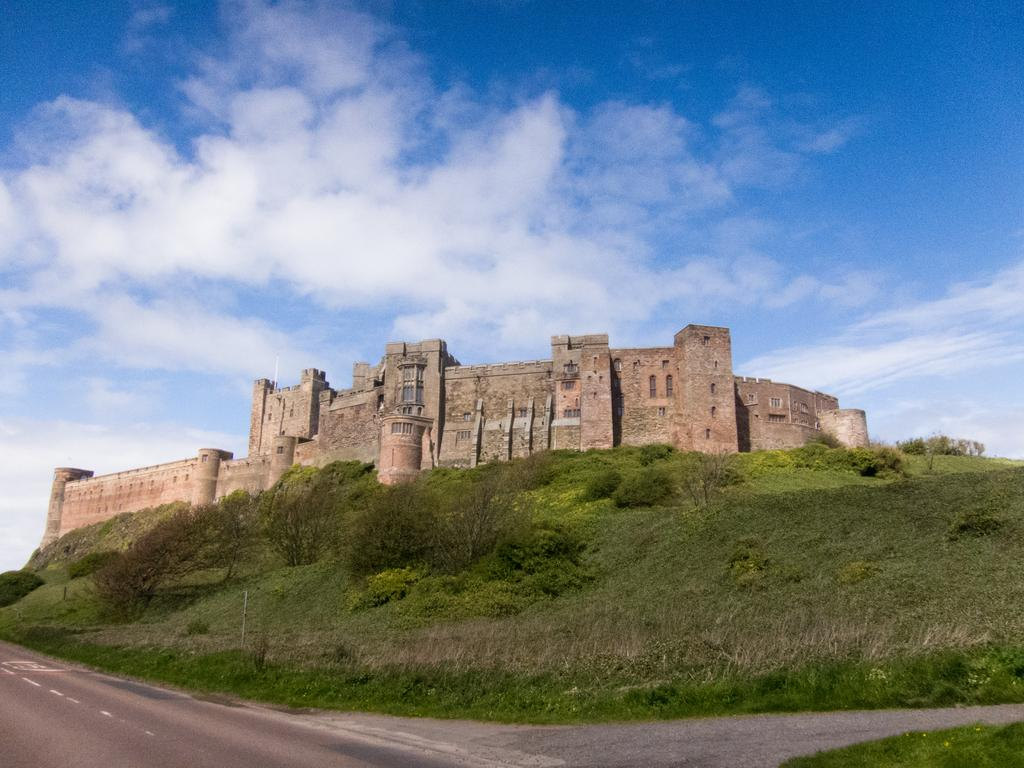What is the main feature in the foreground of the image? There is a road in the foreground of the image. What can be seen in the middle of the image? There is grass land, trees, and a castle in the middle of the image. What is visible at the top of the image? The sky is visible at the top of the image. What type of furniture can be seen in the image? There is no furniture present in the image. Can you spot any fish swimming in the grass land? There are no fish present in the image; it features a road, grass land, trees, a castle, and the sky. 